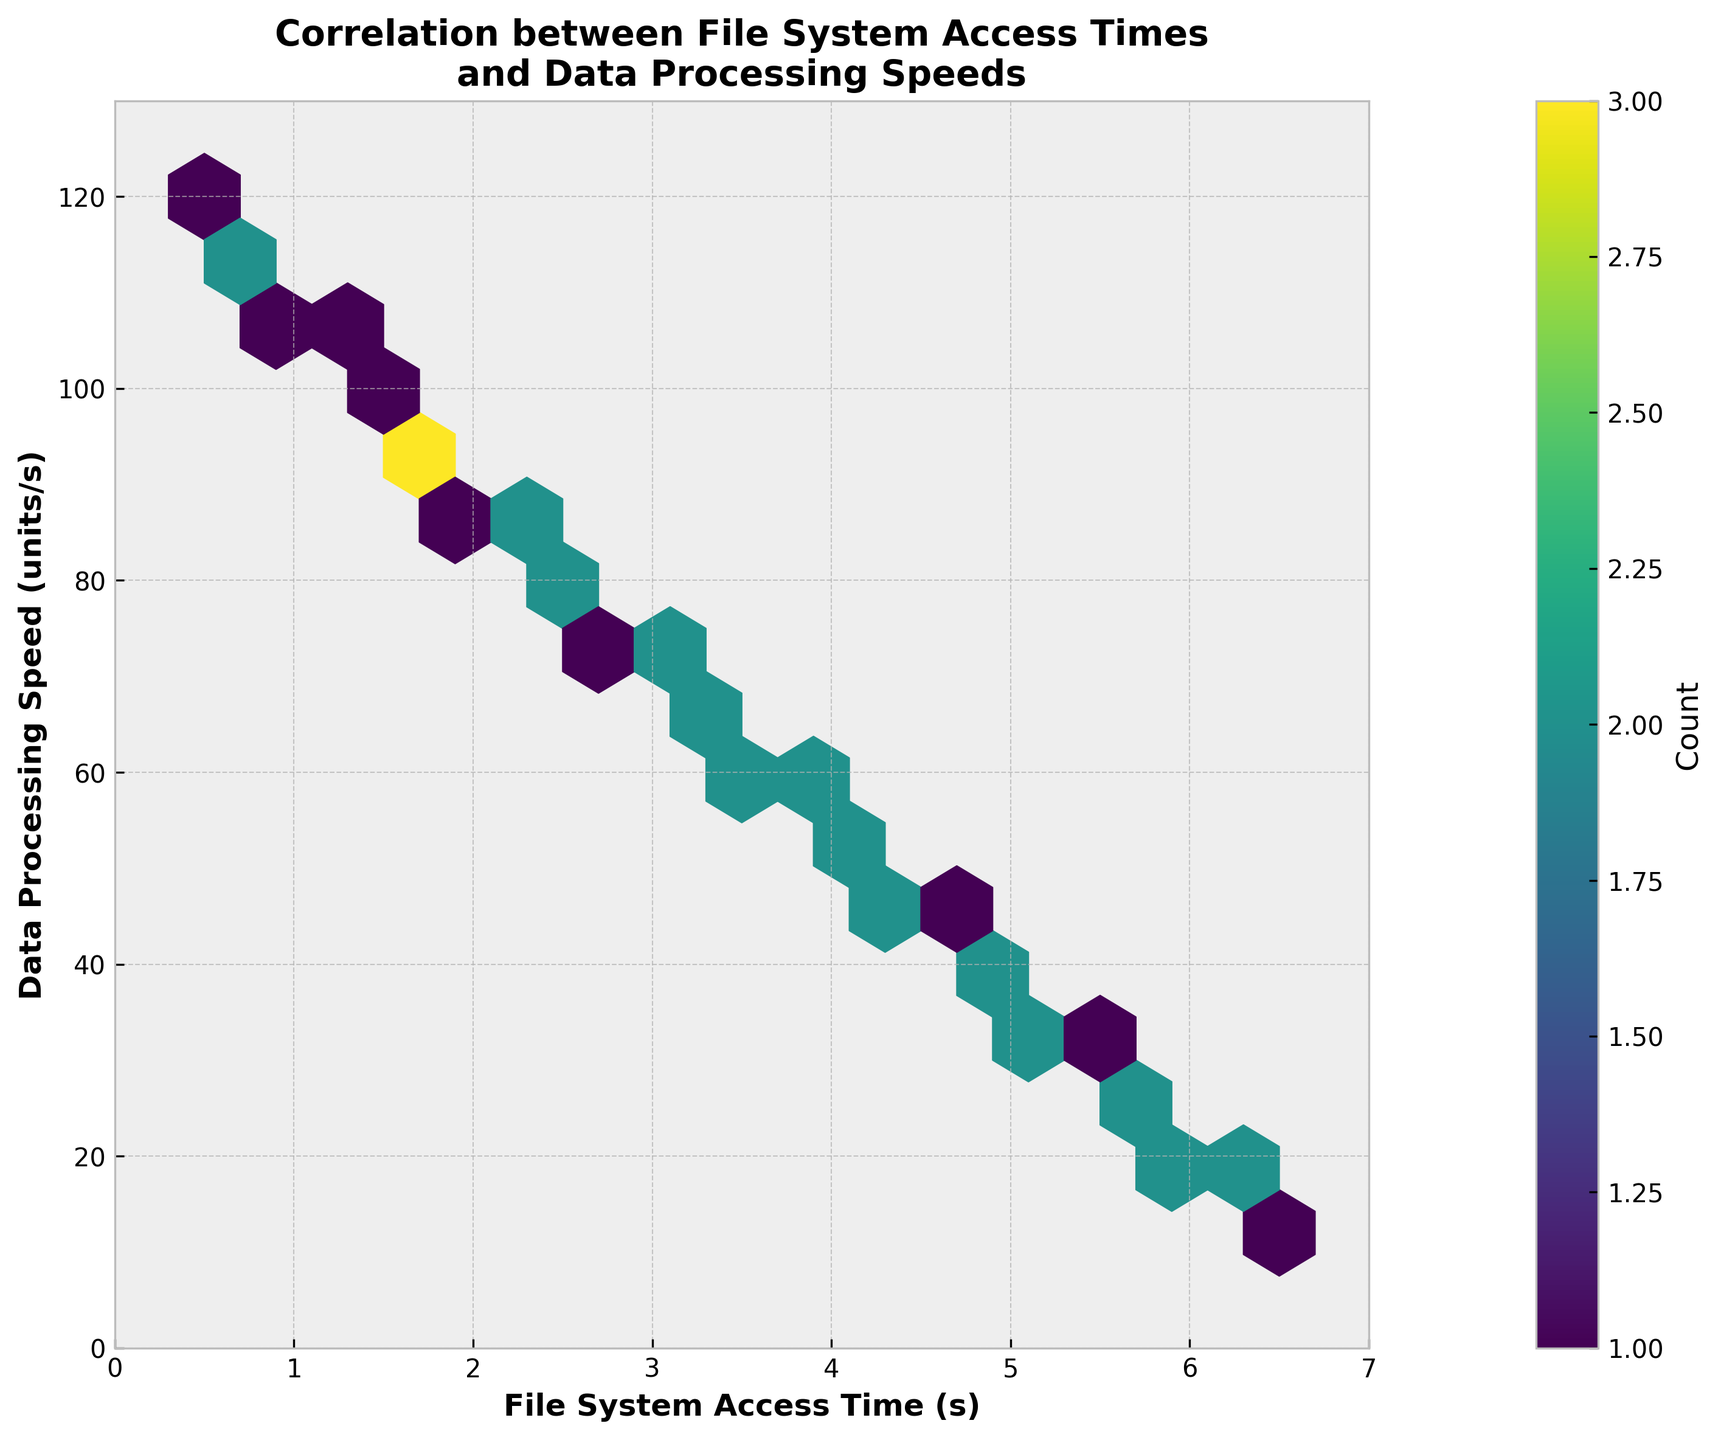What is the title of the plot? The title is usually located at the top of the figure. In this case, it's bold and clearly describes the plot's content.
Answer: Correlation between File System Access Times and Data Processing Speeds What do the axes represent? The x-axis and y-axis labels provide this information. The x-axis shows "File System Access Time (s)", and the y-axis shows "Data Processing Speed (units/s)".
Answer: File System Access Time and Data Processing Speed What is the color bar showing? The color bar, located next to the plot, indicates the count of data points within each hexbin. The label on the color bar is "Count".
Answer: The count of data points How does the data processing speed change with increasing file system access time? Observing the hexbin plot, it can be seen that as the file system access time increases, the data processing speed decreases. They share an inverse relationship.
Answer: Decreases Where is the highest concentration of data points located? The regions with the highest concentration of data points are indicated by the darkest shade in the hexbin plot. This appears to be around the lower left corner of the plot. Specifically, between 0.5 to 1.0 seconds of access time and 100 to 120 units/s of processing speed.
Answer: 0.5 to 1.0 seconds and 100 to 120 units/s Estimate the data processing speed when the file system access time is around 3.5 seconds. By locating 3.5 seconds on the x-axis and looking at the corresponding y-values, the processing speeds are around 60 to 70 units/s.
Answer: 60 to 70 units/s How are the colors in the hexbins linked to the data points? The colors range from light to dark within the hexbin plot, where darker colors mean a higher concentration of data points within that specific bin.
Answer: Darker colors mean higher data point concentration What is the range of file system access times represented in the plot? The x-axis range, as given in the plot, shows file system access times from 0 to 7 seconds.
Answer: 0 to 7 seconds What is the relationship between the density of data points and the processing speed around 2.5 seconds access time? By looking at the plot around the 2.5 seconds mark, there is a noticeable density around 80 to 85 units/s of processing speed. This indicates a higher density of data points at this range.
Answer: 80 to 85 units/s 